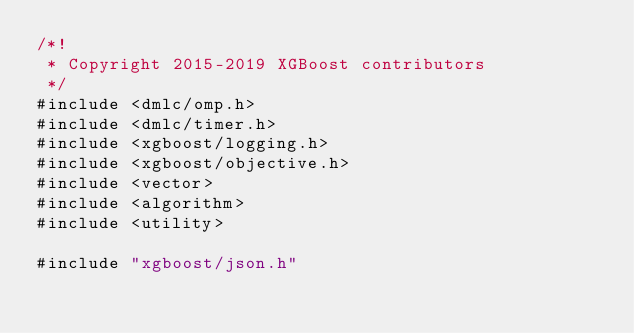<code> <loc_0><loc_0><loc_500><loc_500><_Cuda_>/*!
 * Copyright 2015-2019 XGBoost contributors
 */
#include <dmlc/omp.h>
#include <dmlc/timer.h>
#include <xgboost/logging.h>
#include <xgboost/objective.h>
#include <vector>
#include <algorithm>
#include <utility>

#include "xgboost/json.h"</code> 